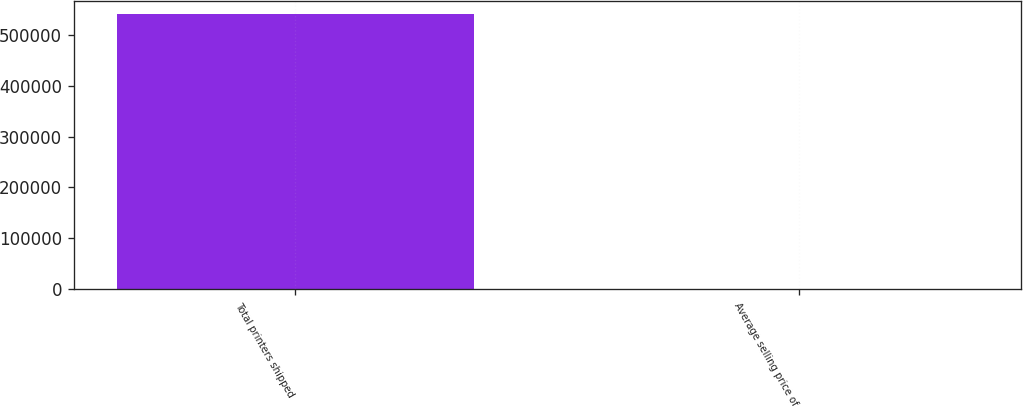Convert chart. <chart><loc_0><loc_0><loc_500><loc_500><bar_chart><fcel>Total printers shipped<fcel>Average selling price of<nl><fcel>540431<fcel>627<nl></chart> 